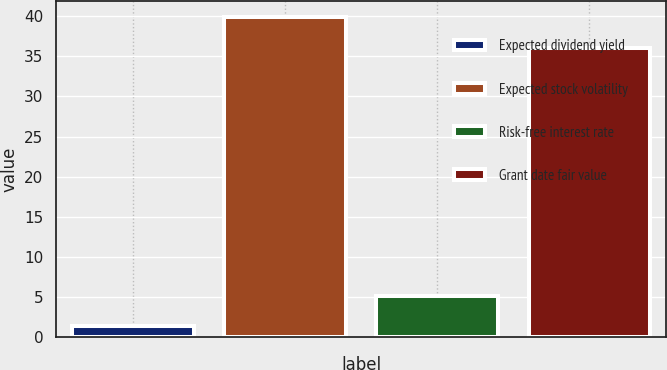Convert chart. <chart><loc_0><loc_0><loc_500><loc_500><bar_chart><fcel>Expected dividend yield<fcel>Expected stock volatility<fcel>Risk-free interest rate<fcel>Grant date fair value<nl><fcel>1.39<fcel>39.84<fcel>5.15<fcel>36.08<nl></chart> 